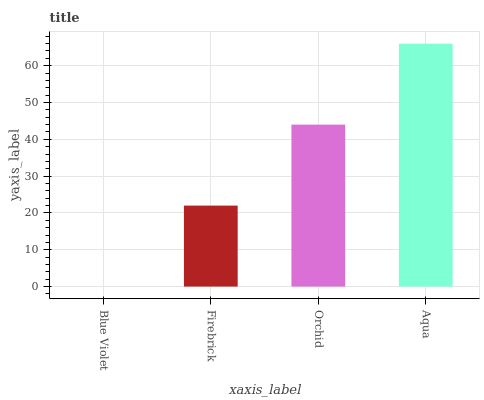Is Blue Violet the minimum?
Answer yes or no. Yes. Is Aqua the maximum?
Answer yes or no. Yes. Is Firebrick the minimum?
Answer yes or no. No. Is Firebrick the maximum?
Answer yes or no. No. Is Firebrick greater than Blue Violet?
Answer yes or no. Yes. Is Blue Violet less than Firebrick?
Answer yes or no. Yes. Is Blue Violet greater than Firebrick?
Answer yes or no. No. Is Firebrick less than Blue Violet?
Answer yes or no. No. Is Orchid the high median?
Answer yes or no. Yes. Is Firebrick the low median?
Answer yes or no. Yes. Is Aqua the high median?
Answer yes or no. No. Is Orchid the low median?
Answer yes or no. No. 